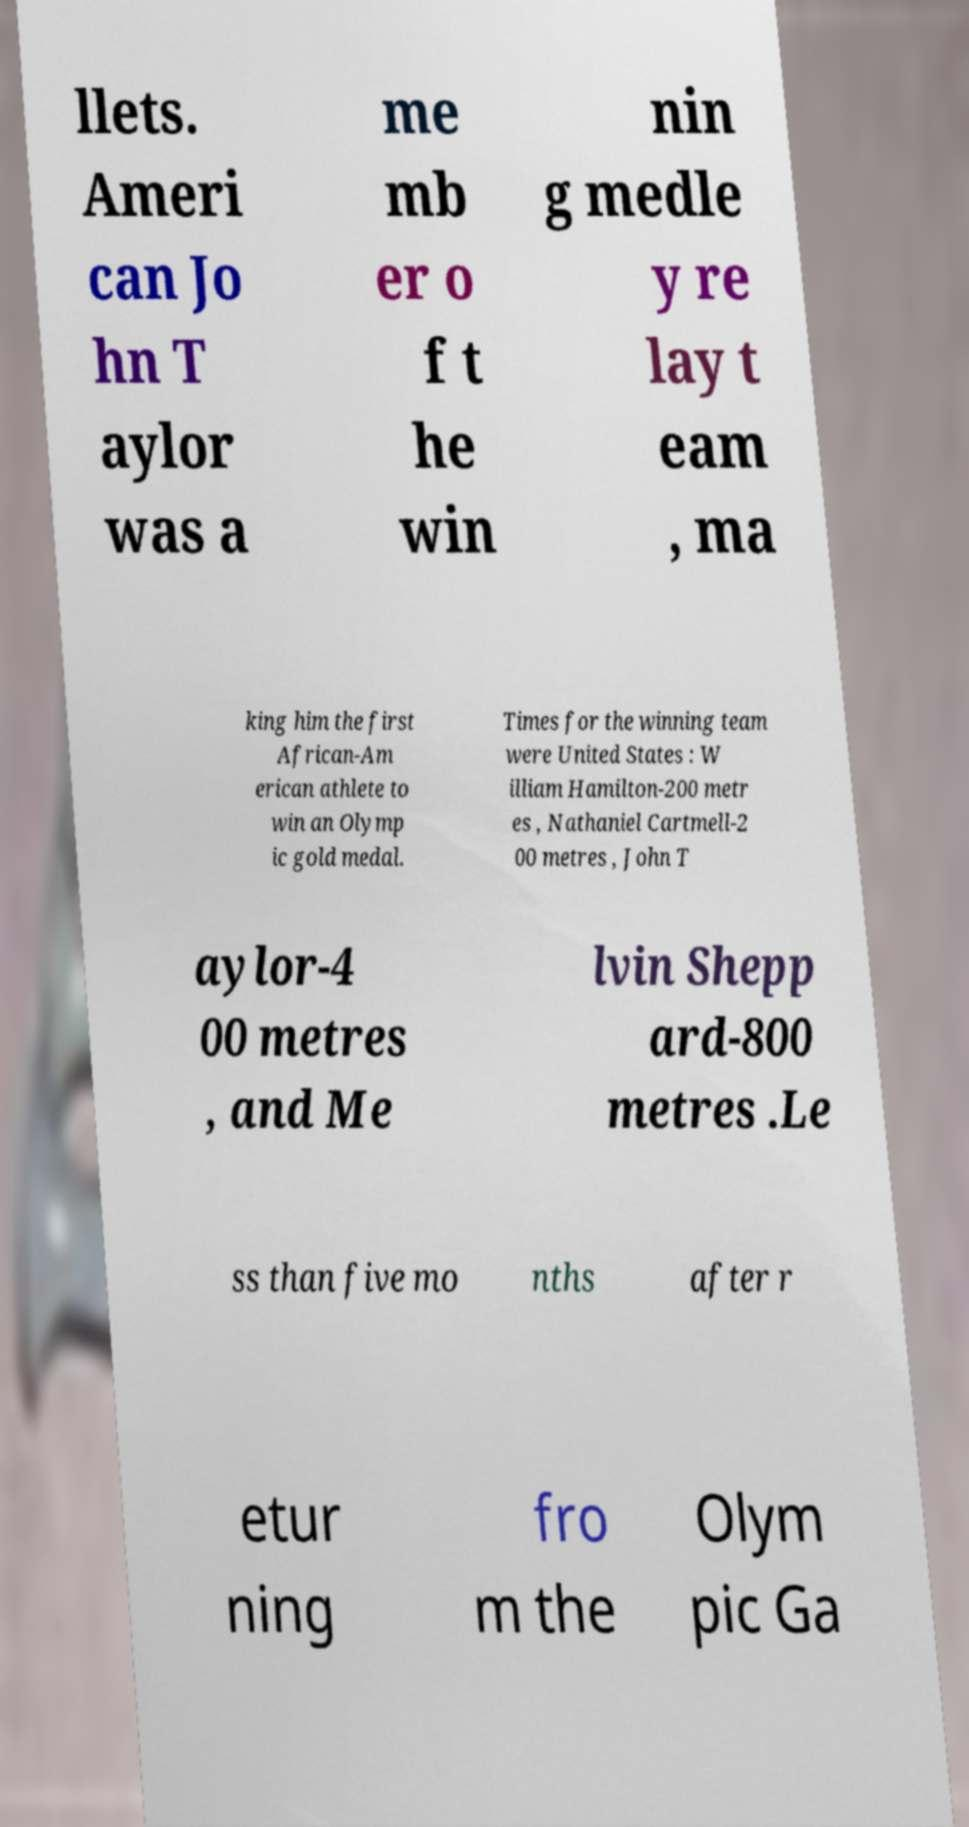Please read and relay the text visible in this image. What does it say? llets. Ameri can Jo hn T aylor was a me mb er o f t he win nin g medle y re lay t eam , ma king him the first African-Am erican athlete to win an Olymp ic gold medal. Times for the winning team were United States : W illiam Hamilton-200 metr es , Nathaniel Cartmell-2 00 metres , John T aylor-4 00 metres , and Me lvin Shepp ard-800 metres .Le ss than five mo nths after r etur ning fro m the Olym pic Ga 